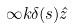<formula> <loc_0><loc_0><loc_500><loc_500>\infty k \delta ( s ) \hat { z }</formula> 